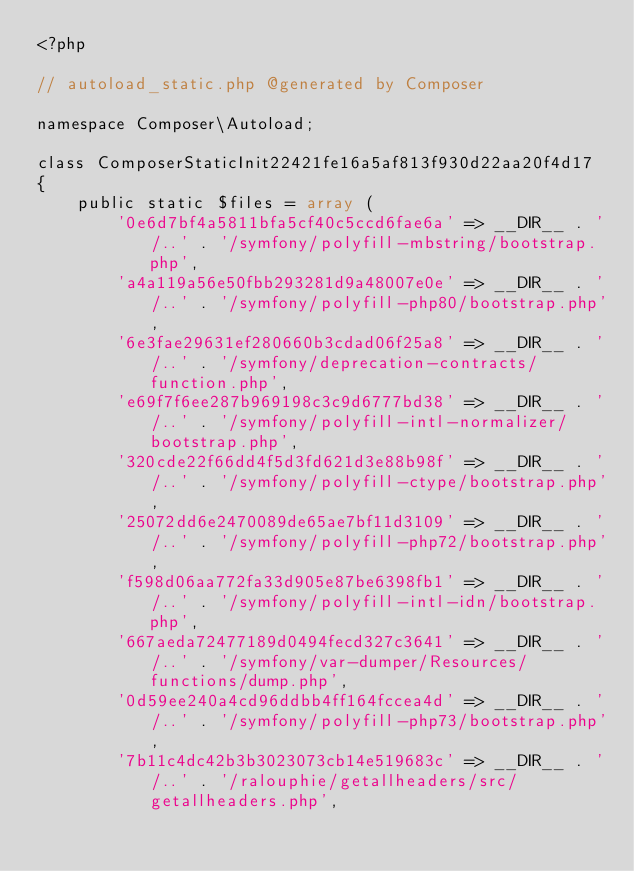Convert code to text. <code><loc_0><loc_0><loc_500><loc_500><_PHP_><?php

// autoload_static.php @generated by Composer

namespace Composer\Autoload;

class ComposerStaticInit22421fe16a5af813f930d22aa20f4d17
{
    public static $files = array (
        '0e6d7bf4a5811bfa5cf40c5ccd6fae6a' => __DIR__ . '/..' . '/symfony/polyfill-mbstring/bootstrap.php',
        'a4a119a56e50fbb293281d9a48007e0e' => __DIR__ . '/..' . '/symfony/polyfill-php80/bootstrap.php',
        '6e3fae29631ef280660b3cdad06f25a8' => __DIR__ . '/..' . '/symfony/deprecation-contracts/function.php',
        'e69f7f6ee287b969198c3c9d6777bd38' => __DIR__ . '/..' . '/symfony/polyfill-intl-normalizer/bootstrap.php',
        '320cde22f66dd4f5d3fd621d3e88b98f' => __DIR__ . '/..' . '/symfony/polyfill-ctype/bootstrap.php',
        '25072dd6e2470089de65ae7bf11d3109' => __DIR__ . '/..' . '/symfony/polyfill-php72/bootstrap.php',
        'f598d06aa772fa33d905e87be6398fb1' => __DIR__ . '/..' . '/symfony/polyfill-intl-idn/bootstrap.php',
        '667aeda72477189d0494fecd327c3641' => __DIR__ . '/..' . '/symfony/var-dumper/Resources/functions/dump.php',
        '0d59ee240a4cd96ddbb4ff164fccea4d' => __DIR__ . '/..' . '/symfony/polyfill-php73/bootstrap.php',
        '7b11c4dc42b3b3023073cb14e519683c' => __DIR__ . '/..' . '/ralouphie/getallheaders/src/getallheaders.php',</code> 